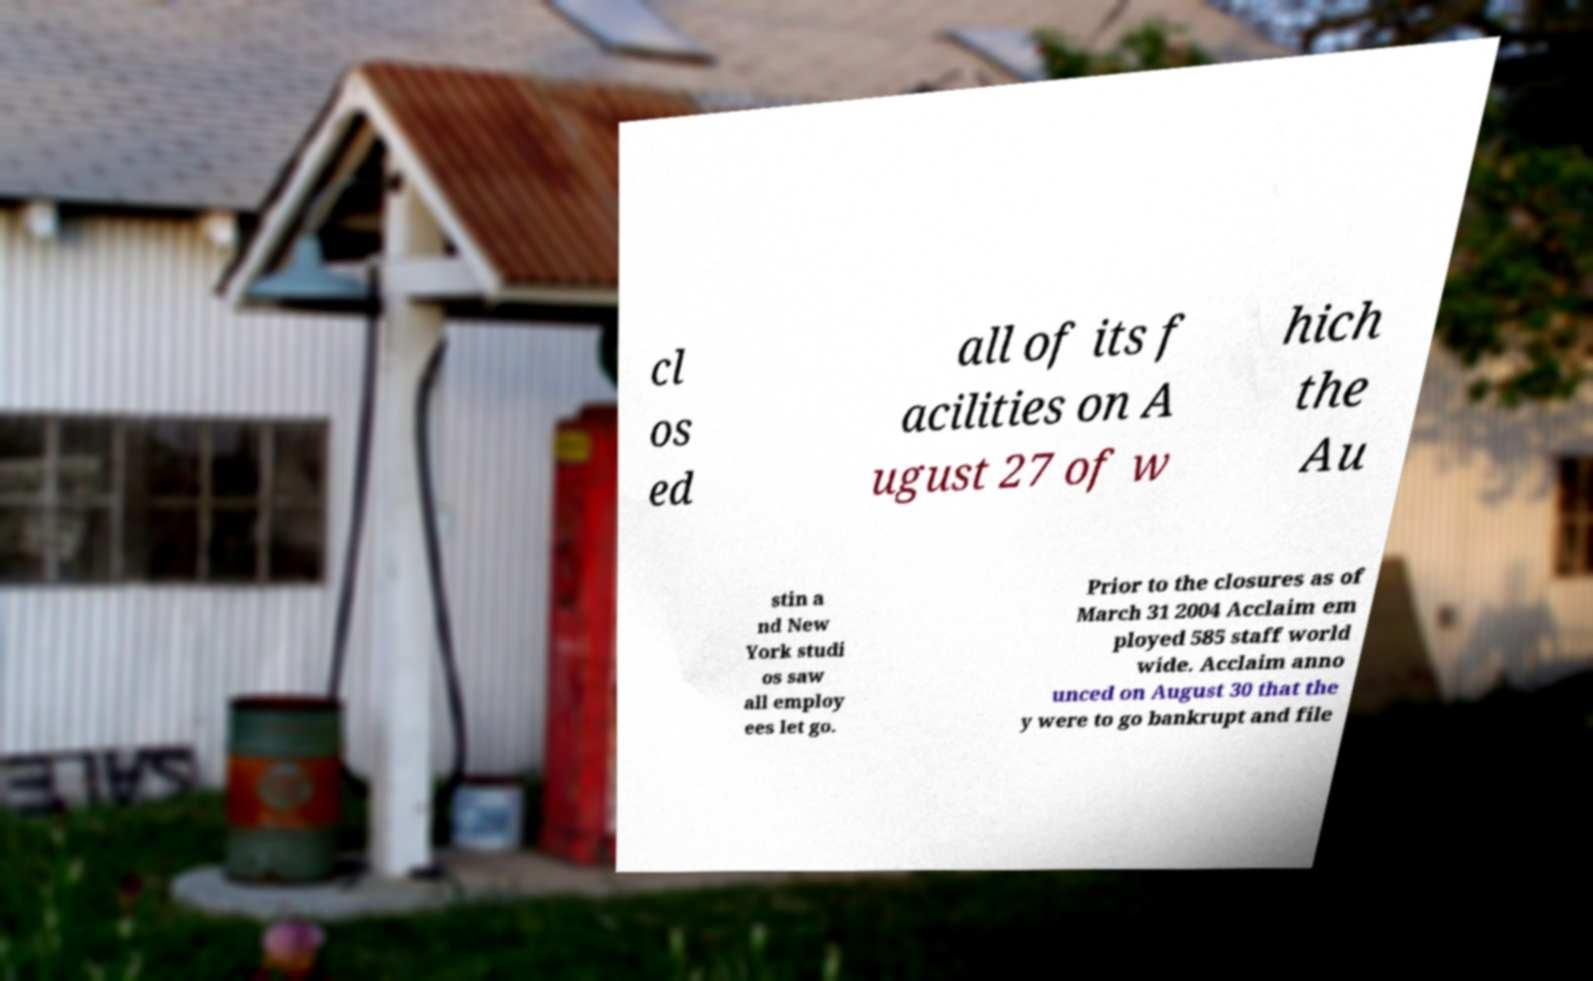Please read and relay the text visible in this image. What does it say? cl os ed all of its f acilities on A ugust 27 of w hich the Au stin a nd New York studi os saw all employ ees let go. Prior to the closures as of March 31 2004 Acclaim em ployed 585 staff world wide. Acclaim anno unced on August 30 that the y were to go bankrupt and file 